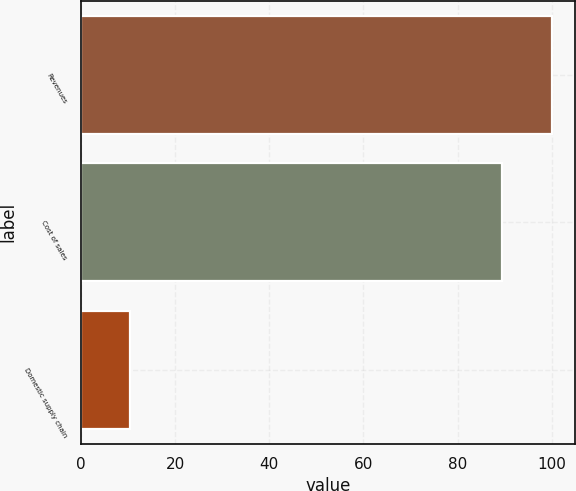Convert chart. <chart><loc_0><loc_0><loc_500><loc_500><bar_chart><fcel>Revenues<fcel>Cost of sales<fcel>Domestic supply chain<nl><fcel>100<fcel>89.5<fcel>10.5<nl></chart> 